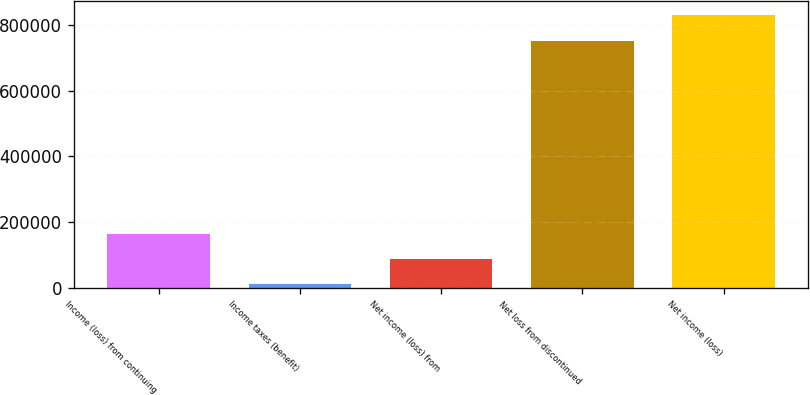<chart> <loc_0><loc_0><loc_500><loc_500><bar_chart><fcel>Income (loss) from continuing<fcel>Income taxes (benefit)<fcel>Net income (loss) from<fcel>Net loss from discontinued<fcel>Net income (loss)<nl><fcel>164799<fcel>10351<fcel>87574.9<fcel>752386<fcel>829610<nl></chart> 